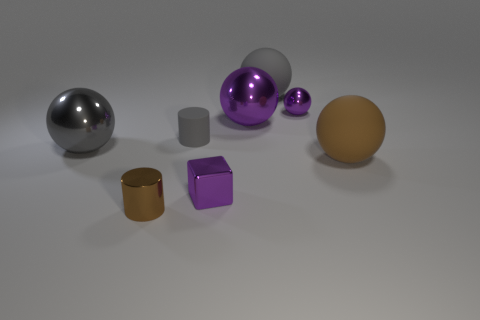Add 1 small yellow rubber spheres. How many objects exist? 9 Subtract all gray metallic spheres. How many spheres are left? 4 Subtract all brown cylinders. How many cylinders are left? 1 Subtract 2 cylinders. How many cylinders are left? 0 Subtract all blocks. How many objects are left? 7 Add 3 tiny brown shiny cylinders. How many tiny brown shiny cylinders exist? 4 Subtract 0 red cylinders. How many objects are left? 8 Subtract all red balls. Subtract all purple cylinders. How many balls are left? 5 Subtract all yellow cubes. How many gray cylinders are left? 1 Subtract all purple blocks. Subtract all purple metal objects. How many objects are left? 4 